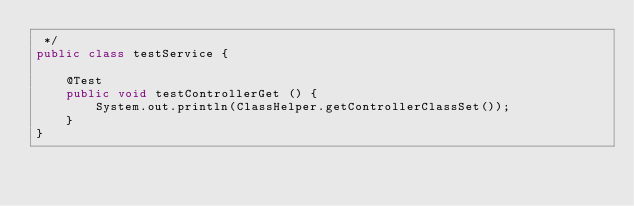<code> <loc_0><loc_0><loc_500><loc_500><_Java_> */
public class testService {

    @Test
    public void testControllerGet () {
        System.out.println(ClassHelper.getControllerClassSet());
    }
}
</code> 